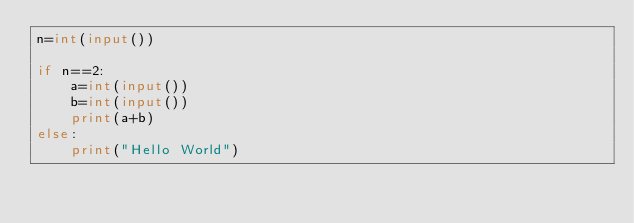<code> <loc_0><loc_0><loc_500><loc_500><_Python_>n=int(input())

if n==2:
    a=int(input())
    b=int(input())
    print(a+b)
else:
    print("Hello World")</code> 